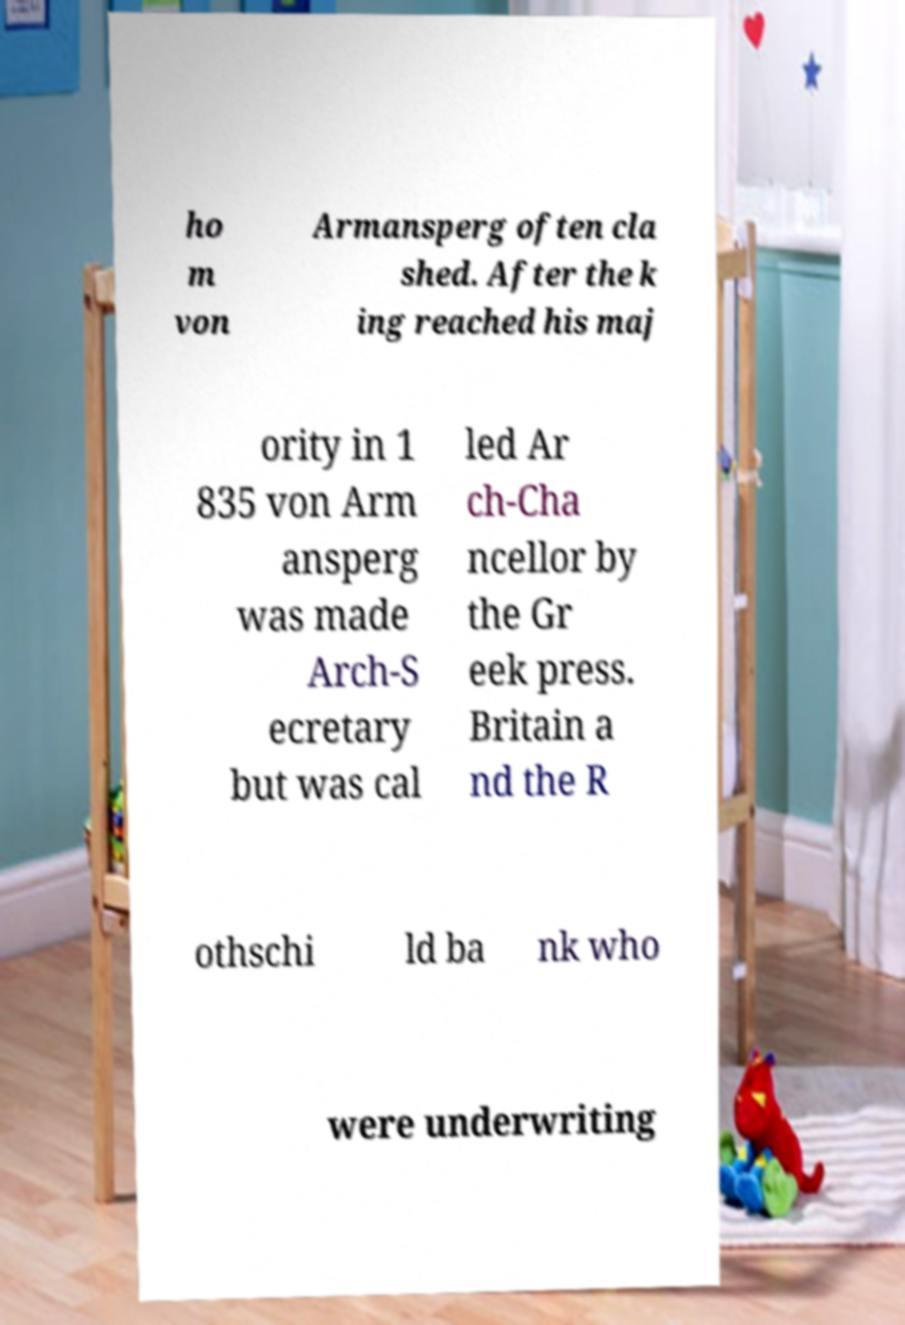Could you assist in decoding the text presented in this image and type it out clearly? ho m von Armansperg often cla shed. After the k ing reached his maj ority in 1 835 von Arm ansperg was made Arch-S ecretary but was cal led Ar ch-Cha ncellor by the Gr eek press. Britain a nd the R othschi ld ba nk who were underwriting 